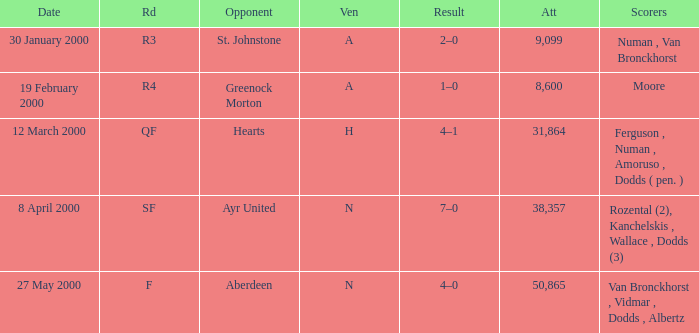What venue was on 27 May 2000? N. I'm looking to parse the entire table for insights. Could you assist me with that? {'header': ['Date', 'Rd', 'Opponent', 'Ven', 'Result', 'Att', 'Scorers'], 'rows': [['30 January 2000', 'R3', 'St. Johnstone', 'A', '2–0', '9,099', 'Numan , Van Bronckhorst'], ['19 February 2000', 'R4', 'Greenock Morton', 'A', '1–0', '8,600', 'Moore'], ['12 March 2000', 'QF', 'Hearts', 'H', '4–1', '31,864', 'Ferguson , Numan , Amoruso , Dodds ( pen. )'], ['8 April 2000', 'SF', 'Ayr United', 'N', '7–0', '38,357', 'Rozental (2), Kanchelskis , Wallace , Dodds (3)'], ['27 May 2000', 'F', 'Aberdeen', 'N', '4–0', '50,865', 'Van Bronckhorst , Vidmar , Dodds , Albertz']]} 